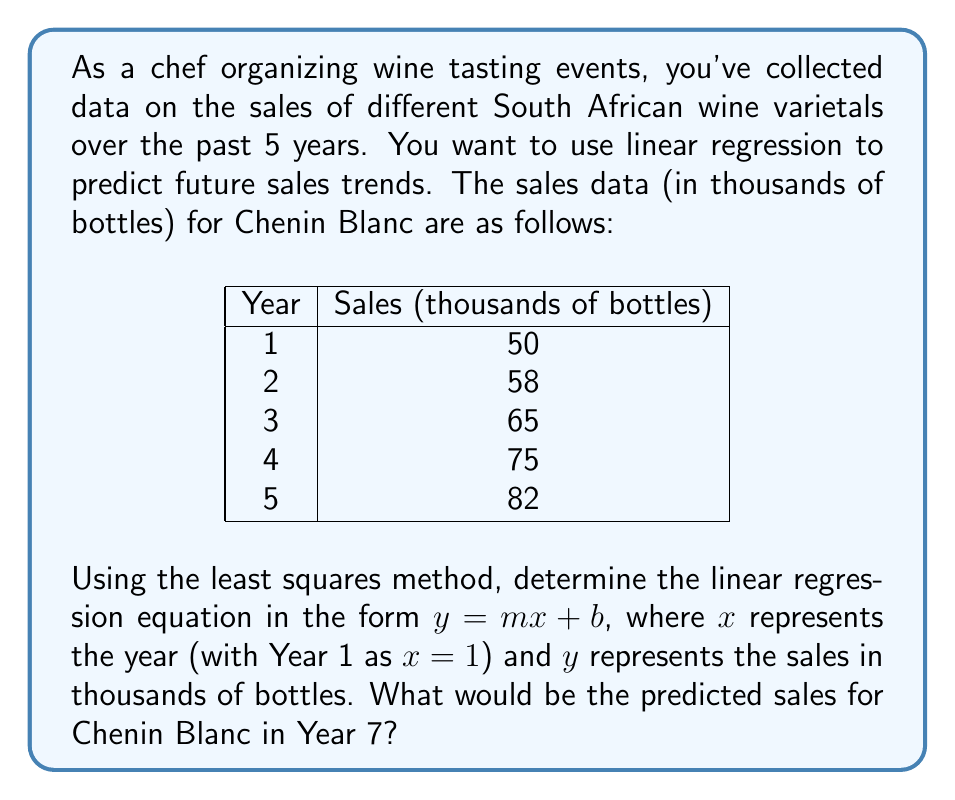Can you answer this question? To find the linear regression equation using the least squares method, we need to calculate the slope $m$ and y-intercept $b$. Let's follow these steps:

1. Calculate the means of $x$ and $y$:
   $\bar{x} = \frac{1 + 2 + 3 + 4 + 5}{5} = 3$
   $\bar{y} = \frac{50 + 58 + 65 + 75 + 82}{5} = 66$

2. Calculate the slope $m$ using the formula:
   $m = \frac{\sum(x_i - \bar{x})(y_i - \bar{y})}{\sum(x_i - \bar{x})^2}$

   Create a table to calculate the required sums:
   | $x_i$ | $y_i$ | $x_i - \bar{x}$ | $y_i - \bar{y}$ | $(x_i - \bar{x})(y_i - \bar{y})$ | $(x_i - \bar{x})^2$ |
   |-------|-------|-----------------|------------------|----------------------------------|----------------------|
   | 1     | 50    | -2              | -16              | 32                               | 4                    |
   | 2     | 58    | -1              | -8               | 8                                | 1                    |
   | 3     | 65    | 0               | -1               | 0                                | 0                    |
   | 4     | 75    | 1               | 9                | 9                                | 1                    |
   | 5     | 82    | 2               | 16               | 32                               | 4                    |
   |       |       |                 | Sum:             | 81                               | 10                   |

   $m = \frac{81}{10} = 8.1$

3. Calculate the y-intercept $b$ using the formula:
   $b = \bar{y} - m\bar{x}$
   $b = 66 - 8.1(3) = 41.7$

4. The linear regression equation is:
   $y = 8.1x + 41.7$

5. To predict sales for Year 7, substitute $x = 7$ into the equation:
   $y = 8.1(7) + 41.7 = 98.4$

Therefore, the predicted sales for Chenin Blanc in Year 7 would be 98.4 thousand bottles.
Answer: 98.4 thousand bottles 